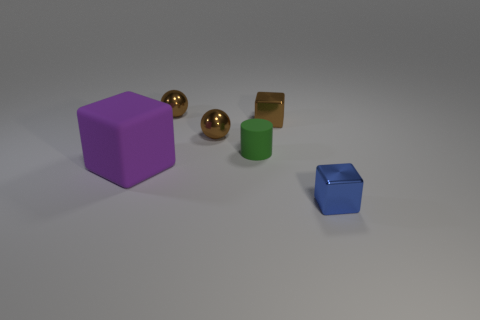How many other objects are there of the same size as the purple matte block? There are no other objects of exactly the same size as the purple matte block. However, there are objects of various sizes, such as two smaller golden spheres, a small green cylinder, and a smaller blue cube. 